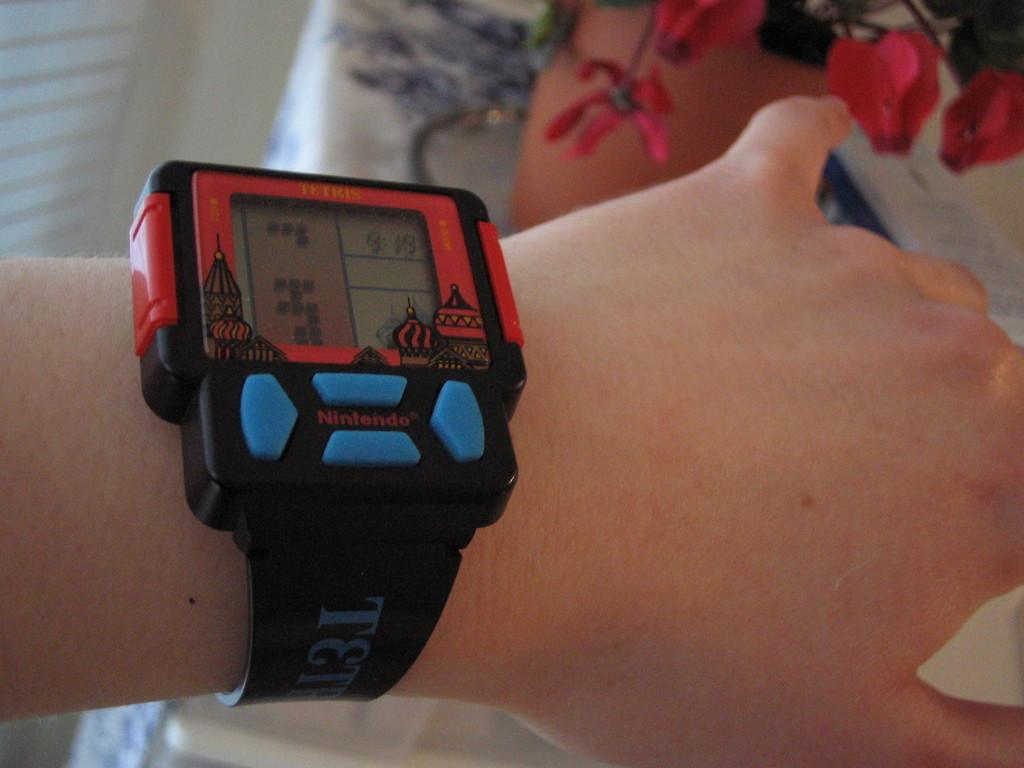<image>
Summarize the visual content of the image. a watch with the letter T on the side of it 